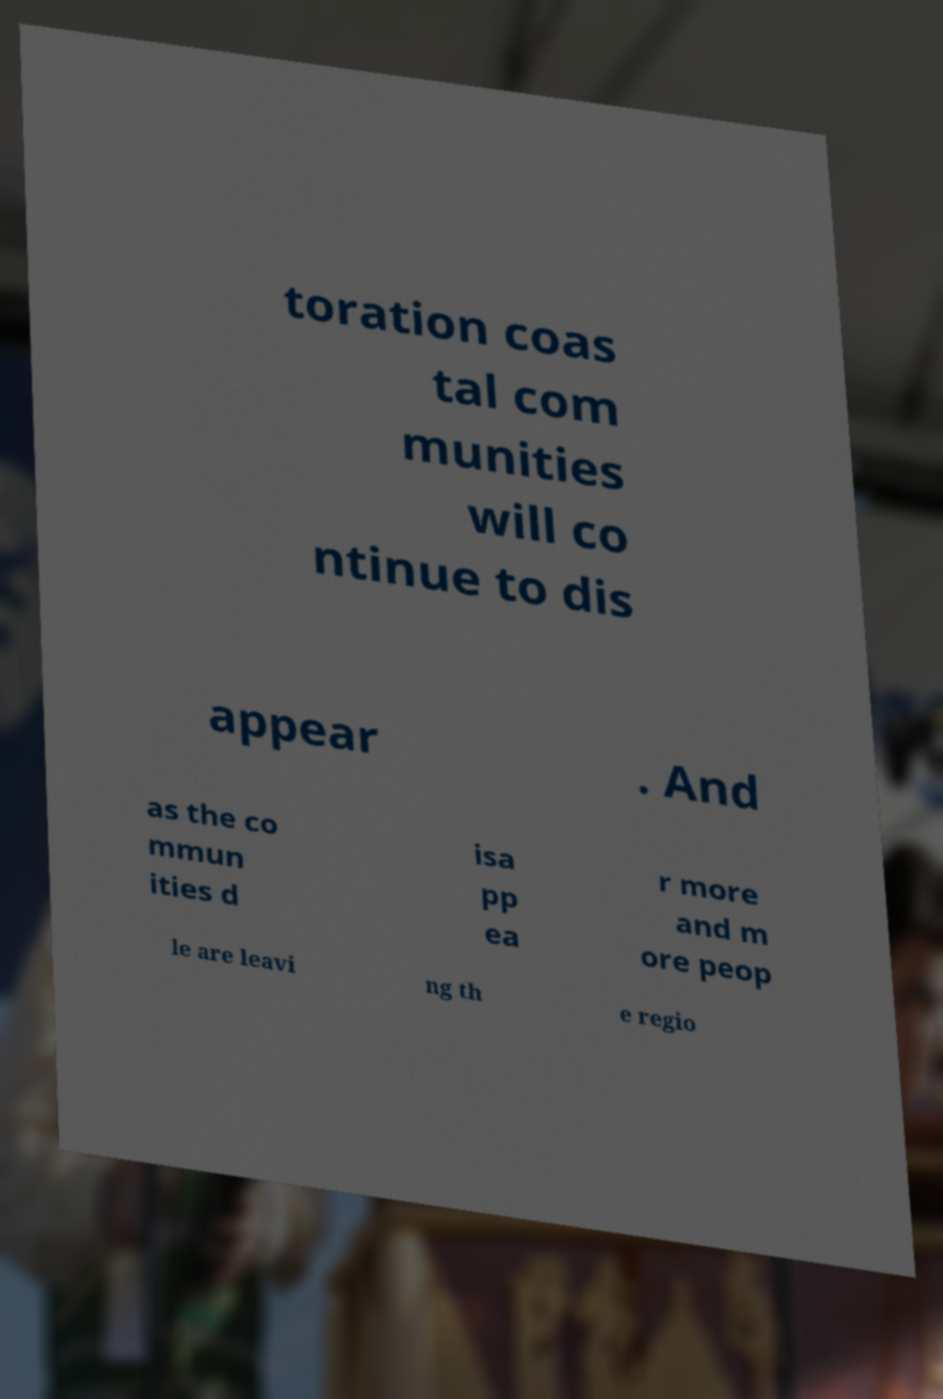I need the written content from this picture converted into text. Can you do that? toration coas tal com munities will co ntinue to dis appear . And as the co mmun ities d isa pp ea r more and m ore peop le are leavi ng th e regio 